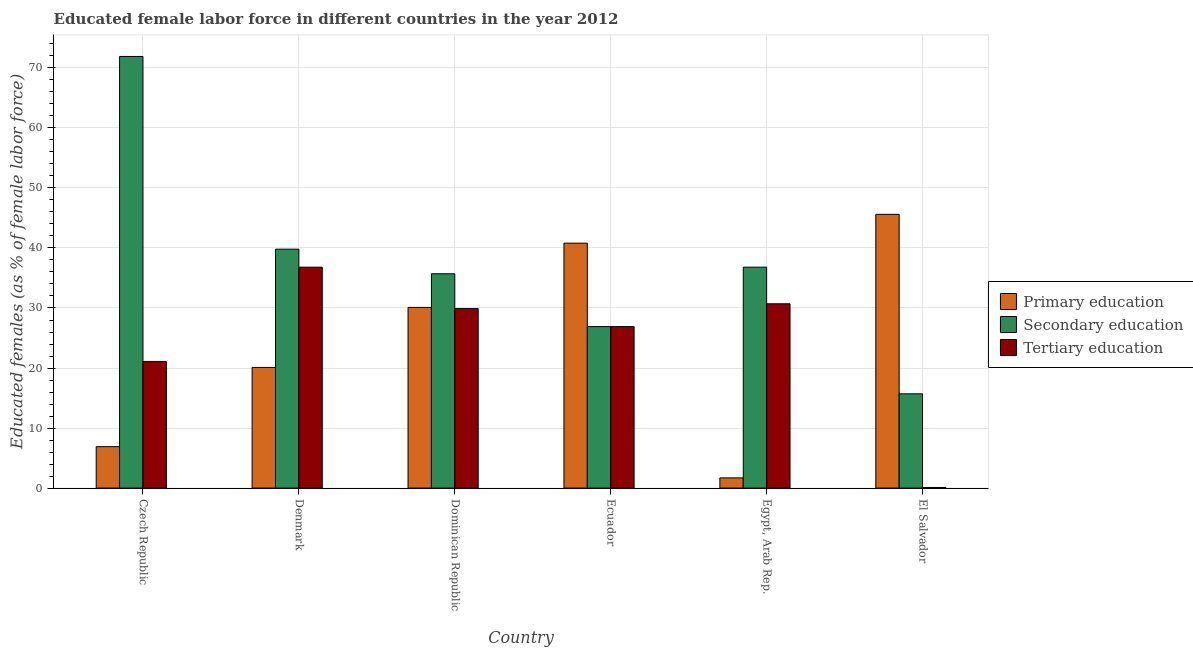How many different coloured bars are there?
Provide a succinct answer. 3. How many groups of bars are there?
Provide a succinct answer. 6. Are the number of bars per tick equal to the number of legend labels?
Offer a very short reply. Yes. Are the number of bars on each tick of the X-axis equal?
Provide a succinct answer. Yes. What is the label of the 1st group of bars from the left?
Your response must be concise. Czech Republic. What is the percentage of female labor force who received secondary education in El Salvador?
Make the answer very short. 15.7. Across all countries, what is the maximum percentage of female labor force who received secondary education?
Your response must be concise. 71.9. Across all countries, what is the minimum percentage of female labor force who received tertiary education?
Your answer should be very brief. 0.1. In which country was the percentage of female labor force who received tertiary education maximum?
Your response must be concise. Denmark. In which country was the percentage of female labor force who received primary education minimum?
Offer a terse response. Egypt, Arab Rep. What is the total percentage of female labor force who received secondary education in the graph?
Ensure brevity in your answer.  226.8. What is the difference between the percentage of female labor force who received tertiary education in Czech Republic and that in Denmark?
Your response must be concise. -15.7. What is the difference between the percentage of female labor force who received tertiary education in Denmark and the percentage of female labor force who received secondary education in Czech Republic?
Your response must be concise. -35.1. What is the average percentage of female labor force who received secondary education per country?
Your response must be concise. 37.8. What is the difference between the percentage of female labor force who received secondary education and percentage of female labor force who received tertiary education in Egypt, Arab Rep.?
Offer a terse response. 6.1. What is the ratio of the percentage of female labor force who received secondary education in Czech Republic to that in Ecuador?
Your response must be concise. 2.67. Is the percentage of female labor force who received secondary education in Czech Republic less than that in Dominican Republic?
Your response must be concise. No. What is the difference between the highest and the second highest percentage of female labor force who received tertiary education?
Ensure brevity in your answer.  6.1. What is the difference between the highest and the lowest percentage of female labor force who received secondary education?
Your response must be concise. 56.2. Is the sum of the percentage of female labor force who received primary education in Czech Republic and Ecuador greater than the maximum percentage of female labor force who received tertiary education across all countries?
Keep it short and to the point. Yes. What does the 3rd bar from the left in Denmark represents?
Your answer should be compact. Tertiary education. What does the 2nd bar from the right in Dominican Republic represents?
Provide a short and direct response. Secondary education. Is it the case that in every country, the sum of the percentage of female labor force who received primary education and percentage of female labor force who received secondary education is greater than the percentage of female labor force who received tertiary education?
Offer a terse response. Yes. How many bars are there?
Make the answer very short. 18. Are all the bars in the graph horizontal?
Provide a short and direct response. No. How many countries are there in the graph?
Provide a succinct answer. 6. Does the graph contain any zero values?
Offer a very short reply. No. Does the graph contain grids?
Provide a short and direct response. Yes. What is the title of the graph?
Give a very brief answer. Educated female labor force in different countries in the year 2012. Does "Textiles and clothing" appear as one of the legend labels in the graph?
Ensure brevity in your answer.  No. What is the label or title of the Y-axis?
Provide a short and direct response. Educated females (as % of female labor force). What is the Educated females (as % of female labor force) in Primary education in Czech Republic?
Your answer should be compact. 6.9. What is the Educated females (as % of female labor force) in Secondary education in Czech Republic?
Make the answer very short. 71.9. What is the Educated females (as % of female labor force) in Tertiary education in Czech Republic?
Make the answer very short. 21.1. What is the Educated females (as % of female labor force) of Primary education in Denmark?
Keep it short and to the point. 20.1. What is the Educated females (as % of female labor force) in Secondary education in Denmark?
Ensure brevity in your answer.  39.8. What is the Educated females (as % of female labor force) of Tertiary education in Denmark?
Your response must be concise. 36.8. What is the Educated females (as % of female labor force) of Primary education in Dominican Republic?
Keep it short and to the point. 30.1. What is the Educated females (as % of female labor force) of Secondary education in Dominican Republic?
Offer a terse response. 35.7. What is the Educated females (as % of female labor force) of Tertiary education in Dominican Republic?
Your answer should be very brief. 29.9. What is the Educated females (as % of female labor force) in Primary education in Ecuador?
Give a very brief answer. 40.8. What is the Educated females (as % of female labor force) in Secondary education in Ecuador?
Your answer should be very brief. 26.9. What is the Educated females (as % of female labor force) of Tertiary education in Ecuador?
Ensure brevity in your answer.  26.9. What is the Educated females (as % of female labor force) in Primary education in Egypt, Arab Rep.?
Give a very brief answer. 1.7. What is the Educated females (as % of female labor force) in Secondary education in Egypt, Arab Rep.?
Offer a very short reply. 36.8. What is the Educated females (as % of female labor force) of Tertiary education in Egypt, Arab Rep.?
Your answer should be compact. 30.7. What is the Educated females (as % of female labor force) of Primary education in El Salvador?
Ensure brevity in your answer.  45.6. What is the Educated females (as % of female labor force) in Secondary education in El Salvador?
Ensure brevity in your answer.  15.7. What is the Educated females (as % of female labor force) of Tertiary education in El Salvador?
Offer a very short reply. 0.1. Across all countries, what is the maximum Educated females (as % of female labor force) in Primary education?
Give a very brief answer. 45.6. Across all countries, what is the maximum Educated females (as % of female labor force) in Secondary education?
Offer a terse response. 71.9. Across all countries, what is the maximum Educated females (as % of female labor force) of Tertiary education?
Offer a terse response. 36.8. Across all countries, what is the minimum Educated females (as % of female labor force) in Primary education?
Provide a succinct answer. 1.7. Across all countries, what is the minimum Educated females (as % of female labor force) of Secondary education?
Give a very brief answer. 15.7. Across all countries, what is the minimum Educated females (as % of female labor force) of Tertiary education?
Provide a succinct answer. 0.1. What is the total Educated females (as % of female labor force) of Primary education in the graph?
Offer a terse response. 145.2. What is the total Educated females (as % of female labor force) of Secondary education in the graph?
Ensure brevity in your answer.  226.8. What is the total Educated females (as % of female labor force) of Tertiary education in the graph?
Provide a short and direct response. 145.5. What is the difference between the Educated females (as % of female labor force) in Secondary education in Czech Republic and that in Denmark?
Your answer should be very brief. 32.1. What is the difference between the Educated females (as % of female labor force) of Tertiary education in Czech Republic and that in Denmark?
Provide a succinct answer. -15.7. What is the difference between the Educated females (as % of female labor force) of Primary education in Czech Republic and that in Dominican Republic?
Your answer should be very brief. -23.2. What is the difference between the Educated females (as % of female labor force) of Secondary education in Czech Republic and that in Dominican Republic?
Your answer should be compact. 36.2. What is the difference between the Educated females (as % of female labor force) of Tertiary education in Czech Republic and that in Dominican Republic?
Your answer should be very brief. -8.8. What is the difference between the Educated females (as % of female labor force) in Primary education in Czech Republic and that in Ecuador?
Make the answer very short. -33.9. What is the difference between the Educated females (as % of female labor force) in Primary education in Czech Republic and that in Egypt, Arab Rep.?
Your answer should be compact. 5.2. What is the difference between the Educated females (as % of female labor force) of Secondary education in Czech Republic and that in Egypt, Arab Rep.?
Your response must be concise. 35.1. What is the difference between the Educated females (as % of female labor force) of Primary education in Czech Republic and that in El Salvador?
Keep it short and to the point. -38.7. What is the difference between the Educated females (as % of female labor force) of Secondary education in Czech Republic and that in El Salvador?
Your response must be concise. 56.2. What is the difference between the Educated females (as % of female labor force) in Tertiary education in Czech Republic and that in El Salvador?
Your answer should be compact. 21. What is the difference between the Educated females (as % of female labor force) of Primary education in Denmark and that in Dominican Republic?
Offer a terse response. -10. What is the difference between the Educated females (as % of female labor force) in Secondary education in Denmark and that in Dominican Republic?
Provide a short and direct response. 4.1. What is the difference between the Educated females (as % of female labor force) of Tertiary education in Denmark and that in Dominican Republic?
Your answer should be compact. 6.9. What is the difference between the Educated females (as % of female labor force) in Primary education in Denmark and that in Ecuador?
Provide a short and direct response. -20.7. What is the difference between the Educated females (as % of female labor force) of Secondary education in Denmark and that in Ecuador?
Your response must be concise. 12.9. What is the difference between the Educated females (as % of female labor force) of Tertiary education in Denmark and that in Ecuador?
Provide a succinct answer. 9.9. What is the difference between the Educated females (as % of female labor force) of Primary education in Denmark and that in El Salvador?
Provide a short and direct response. -25.5. What is the difference between the Educated females (as % of female labor force) in Secondary education in Denmark and that in El Salvador?
Your response must be concise. 24.1. What is the difference between the Educated females (as % of female labor force) of Tertiary education in Denmark and that in El Salvador?
Your response must be concise. 36.7. What is the difference between the Educated females (as % of female labor force) of Primary education in Dominican Republic and that in Ecuador?
Offer a very short reply. -10.7. What is the difference between the Educated females (as % of female labor force) of Secondary education in Dominican Republic and that in Ecuador?
Make the answer very short. 8.8. What is the difference between the Educated females (as % of female labor force) of Primary education in Dominican Republic and that in Egypt, Arab Rep.?
Your response must be concise. 28.4. What is the difference between the Educated females (as % of female labor force) of Primary education in Dominican Republic and that in El Salvador?
Keep it short and to the point. -15.5. What is the difference between the Educated females (as % of female labor force) of Secondary education in Dominican Republic and that in El Salvador?
Provide a succinct answer. 20. What is the difference between the Educated females (as % of female labor force) in Tertiary education in Dominican Republic and that in El Salvador?
Your answer should be very brief. 29.8. What is the difference between the Educated females (as % of female labor force) of Primary education in Ecuador and that in Egypt, Arab Rep.?
Provide a succinct answer. 39.1. What is the difference between the Educated females (as % of female labor force) in Tertiary education in Ecuador and that in Egypt, Arab Rep.?
Ensure brevity in your answer.  -3.8. What is the difference between the Educated females (as % of female labor force) in Primary education in Ecuador and that in El Salvador?
Give a very brief answer. -4.8. What is the difference between the Educated females (as % of female labor force) in Secondary education in Ecuador and that in El Salvador?
Your answer should be very brief. 11.2. What is the difference between the Educated females (as % of female labor force) of Tertiary education in Ecuador and that in El Salvador?
Provide a short and direct response. 26.8. What is the difference between the Educated females (as % of female labor force) in Primary education in Egypt, Arab Rep. and that in El Salvador?
Offer a very short reply. -43.9. What is the difference between the Educated females (as % of female labor force) in Secondary education in Egypt, Arab Rep. and that in El Salvador?
Ensure brevity in your answer.  21.1. What is the difference between the Educated females (as % of female labor force) of Tertiary education in Egypt, Arab Rep. and that in El Salvador?
Give a very brief answer. 30.6. What is the difference between the Educated females (as % of female labor force) in Primary education in Czech Republic and the Educated females (as % of female labor force) in Secondary education in Denmark?
Offer a very short reply. -32.9. What is the difference between the Educated females (as % of female labor force) in Primary education in Czech Republic and the Educated females (as % of female labor force) in Tertiary education in Denmark?
Give a very brief answer. -29.9. What is the difference between the Educated females (as % of female labor force) in Secondary education in Czech Republic and the Educated females (as % of female labor force) in Tertiary education in Denmark?
Offer a terse response. 35.1. What is the difference between the Educated females (as % of female labor force) in Primary education in Czech Republic and the Educated females (as % of female labor force) in Secondary education in Dominican Republic?
Make the answer very short. -28.8. What is the difference between the Educated females (as % of female labor force) of Secondary education in Czech Republic and the Educated females (as % of female labor force) of Tertiary education in Dominican Republic?
Provide a succinct answer. 42. What is the difference between the Educated females (as % of female labor force) of Primary education in Czech Republic and the Educated females (as % of female labor force) of Secondary education in Ecuador?
Provide a short and direct response. -20. What is the difference between the Educated females (as % of female labor force) in Secondary education in Czech Republic and the Educated females (as % of female labor force) in Tertiary education in Ecuador?
Make the answer very short. 45. What is the difference between the Educated females (as % of female labor force) in Primary education in Czech Republic and the Educated females (as % of female labor force) in Secondary education in Egypt, Arab Rep.?
Provide a short and direct response. -29.9. What is the difference between the Educated females (as % of female labor force) in Primary education in Czech Republic and the Educated females (as % of female labor force) in Tertiary education in Egypt, Arab Rep.?
Your response must be concise. -23.8. What is the difference between the Educated females (as % of female labor force) in Secondary education in Czech Republic and the Educated females (as % of female labor force) in Tertiary education in Egypt, Arab Rep.?
Make the answer very short. 41.2. What is the difference between the Educated females (as % of female labor force) in Primary education in Czech Republic and the Educated females (as % of female labor force) in Secondary education in El Salvador?
Give a very brief answer. -8.8. What is the difference between the Educated females (as % of female labor force) in Secondary education in Czech Republic and the Educated females (as % of female labor force) in Tertiary education in El Salvador?
Keep it short and to the point. 71.8. What is the difference between the Educated females (as % of female labor force) in Primary education in Denmark and the Educated females (as % of female labor force) in Secondary education in Dominican Republic?
Give a very brief answer. -15.6. What is the difference between the Educated females (as % of female labor force) of Primary education in Denmark and the Educated females (as % of female labor force) of Tertiary education in Dominican Republic?
Give a very brief answer. -9.8. What is the difference between the Educated females (as % of female labor force) in Secondary education in Denmark and the Educated females (as % of female labor force) in Tertiary education in Dominican Republic?
Your response must be concise. 9.9. What is the difference between the Educated females (as % of female labor force) of Secondary education in Denmark and the Educated females (as % of female labor force) of Tertiary education in Ecuador?
Keep it short and to the point. 12.9. What is the difference between the Educated females (as % of female labor force) of Primary education in Denmark and the Educated females (as % of female labor force) of Secondary education in Egypt, Arab Rep.?
Your answer should be compact. -16.7. What is the difference between the Educated females (as % of female labor force) of Primary education in Denmark and the Educated females (as % of female labor force) of Tertiary education in Egypt, Arab Rep.?
Your response must be concise. -10.6. What is the difference between the Educated females (as % of female labor force) in Primary education in Denmark and the Educated females (as % of female labor force) in Secondary education in El Salvador?
Your answer should be very brief. 4.4. What is the difference between the Educated females (as % of female labor force) of Primary education in Denmark and the Educated females (as % of female labor force) of Tertiary education in El Salvador?
Your answer should be very brief. 20. What is the difference between the Educated females (as % of female labor force) of Secondary education in Denmark and the Educated females (as % of female labor force) of Tertiary education in El Salvador?
Ensure brevity in your answer.  39.7. What is the difference between the Educated females (as % of female labor force) of Primary education in Dominican Republic and the Educated females (as % of female labor force) of Secondary education in Ecuador?
Provide a succinct answer. 3.2. What is the difference between the Educated females (as % of female labor force) in Secondary education in Dominican Republic and the Educated females (as % of female labor force) in Tertiary education in Ecuador?
Offer a very short reply. 8.8. What is the difference between the Educated females (as % of female labor force) of Primary education in Dominican Republic and the Educated females (as % of female labor force) of Tertiary education in Egypt, Arab Rep.?
Offer a very short reply. -0.6. What is the difference between the Educated females (as % of female labor force) in Secondary education in Dominican Republic and the Educated females (as % of female labor force) in Tertiary education in El Salvador?
Give a very brief answer. 35.6. What is the difference between the Educated females (as % of female labor force) in Primary education in Ecuador and the Educated females (as % of female labor force) in Secondary education in El Salvador?
Your answer should be compact. 25.1. What is the difference between the Educated females (as % of female labor force) of Primary education in Ecuador and the Educated females (as % of female labor force) of Tertiary education in El Salvador?
Your response must be concise. 40.7. What is the difference between the Educated females (as % of female labor force) of Secondary education in Ecuador and the Educated females (as % of female labor force) of Tertiary education in El Salvador?
Your answer should be compact. 26.8. What is the difference between the Educated females (as % of female labor force) of Primary education in Egypt, Arab Rep. and the Educated females (as % of female labor force) of Secondary education in El Salvador?
Offer a terse response. -14. What is the difference between the Educated females (as % of female labor force) of Secondary education in Egypt, Arab Rep. and the Educated females (as % of female labor force) of Tertiary education in El Salvador?
Offer a very short reply. 36.7. What is the average Educated females (as % of female labor force) of Primary education per country?
Give a very brief answer. 24.2. What is the average Educated females (as % of female labor force) of Secondary education per country?
Your answer should be very brief. 37.8. What is the average Educated females (as % of female labor force) in Tertiary education per country?
Give a very brief answer. 24.25. What is the difference between the Educated females (as % of female labor force) in Primary education and Educated females (as % of female labor force) in Secondary education in Czech Republic?
Offer a terse response. -65. What is the difference between the Educated females (as % of female labor force) of Primary education and Educated females (as % of female labor force) of Tertiary education in Czech Republic?
Keep it short and to the point. -14.2. What is the difference between the Educated females (as % of female labor force) of Secondary education and Educated females (as % of female labor force) of Tertiary education in Czech Republic?
Provide a succinct answer. 50.8. What is the difference between the Educated females (as % of female labor force) in Primary education and Educated females (as % of female labor force) in Secondary education in Denmark?
Provide a succinct answer. -19.7. What is the difference between the Educated females (as % of female labor force) of Primary education and Educated females (as % of female labor force) of Tertiary education in Denmark?
Provide a succinct answer. -16.7. What is the difference between the Educated females (as % of female labor force) in Secondary education and Educated females (as % of female labor force) in Tertiary education in Denmark?
Your answer should be very brief. 3. What is the difference between the Educated females (as % of female labor force) of Primary education and Educated females (as % of female labor force) of Secondary education in Dominican Republic?
Make the answer very short. -5.6. What is the difference between the Educated females (as % of female labor force) of Primary education and Educated females (as % of female labor force) of Tertiary education in Dominican Republic?
Offer a very short reply. 0.2. What is the difference between the Educated females (as % of female labor force) in Secondary education and Educated females (as % of female labor force) in Tertiary education in Dominican Republic?
Provide a succinct answer. 5.8. What is the difference between the Educated females (as % of female labor force) in Primary education and Educated females (as % of female labor force) in Tertiary education in Ecuador?
Make the answer very short. 13.9. What is the difference between the Educated females (as % of female labor force) of Primary education and Educated females (as % of female labor force) of Secondary education in Egypt, Arab Rep.?
Give a very brief answer. -35.1. What is the difference between the Educated females (as % of female labor force) in Secondary education and Educated females (as % of female labor force) in Tertiary education in Egypt, Arab Rep.?
Your answer should be very brief. 6.1. What is the difference between the Educated females (as % of female labor force) of Primary education and Educated females (as % of female labor force) of Secondary education in El Salvador?
Keep it short and to the point. 29.9. What is the difference between the Educated females (as % of female labor force) in Primary education and Educated females (as % of female labor force) in Tertiary education in El Salvador?
Your answer should be very brief. 45.5. What is the ratio of the Educated females (as % of female labor force) of Primary education in Czech Republic to that in Denmark?
Your answer should be compact. 0.34. What is the ratio of the Educated females (as % of female labor force) of Secondary education in Czech Republic to that in Denmark?
Offer a very short reply. 1.81. What is the ratio of the Educated females (as % of female labor force) of Tertiary education in Czech Republic to that in Denmark?
Provide a short and direct response. 0.57. What is the ratio of the Educated females (as % of female labor force) in Primary education in Czech Republic to that in Dominican Republic?
Give a very brief answer. 0.23. What is the ratio of the Educated females (as % of female labor force) of Secondary education in Czech Republic to that in Dominican Republic?
Provide a short and direct response. 2.01. What is the ratio of the Educated females (as % of female labor force) in Tertiary education in Czech Republic to that in Dominican Republic?
Ensure brevity in your answer.  0.71. What is the ratio of the Educated females (as % of female labor force) in Primary education in Czech Republic to that in Ecuador?
Keep it short and to the point. 0.17. What is the ratio of the Educated females (as % of female labor force) in Secondary education in Czech Republic to that in Ecuador?
Offer a terse response. 2.67. What is the ratio of the Educated females (as % of female labor force) of Tertiary education in Czech Republic to that in Ecuador?
Your response must be concise. 0.78. What is the ratio of the Educated females (as % of female labor force) of Primary education in Czech Republic to that in Egypt, Arab Rep.?
Your answer should be very brief. 4.06. What is the ratio of the Educated females (as % of female labor force) in Secondary education in Czech Republic to that in Egypt, Arab Rep.?
Your answer should be very brief. 1.95. What is the ratio of the Educated females (as % of female labor force) of Tertiary education in Czech Republic to that in Egypt, Arab Rep.?
Ensure brevity in your answer.  0.69. What is the ratio of the Educated females (as % of female labor force) of Primary education in Czech Republic to that in El Salvador?
Offer a terse response. 0.15. What is the ratio of the Educated females (as % of female labor force) of Secondary education in Czech Republic to that in El Salvador?
Ensure brevity in your answer.  4.58. What is the ratio of the Educated females (as % of female labor force) in Tertiary education in Czech Republic to that in El Salvador?
Your answer should be compact. 211. What is the ratio of the Educated females (as % of female labor force) in Primary education in Denmark to that in Dominican Republic?
Your response must be concise. 0.67. What is the ratio of the Educated females (as % of female labor force) in Secondary education in Denmark to that in Dominican Republic?
Offer a very short reply. 1.11. What is the ratio of the Educated females (as % of female labor force) in Tertiary education in Denmark to that in Dominican Republic?
Your response must be concise. 1.23. What is the ratio of the Educated females (as % of female labor force) of Primary education in Denmark to that in Ecuador?
Make the answer very short. 0.49. What is the ratio of the Educated females (as % of female labor force) of Secondary education in Denmark to that in Ecuador?
Give a very brief answer. 1.48. What is the ratio of the Educated females (as % of female labor force) in Tertiary education in Denmark to that in Ecuador?
Provide a succinct answer. 1.37. What is the ratio of the Educated females (as % of female labor force) in Primary education in Denmark to that in Egypt, Arab Rep.?
Provide a succinct answer. 11.82. What is the ratio of the Educated females (as % of female labor force) in Secondary education in Denmark to that in Egypt, Arab Rep.?
Give a very brief answer. 1.08. What is the ratio of the Educated females (as % of female labor force) in Tertiary education in Denmark to that in Egypt, Arab Rep.?
Provide a succinct answer. 1.2. What is the ratio of the Educated females (as % of female labor force) of Primary education in Denmark to that in El Salvador?
Keep it short and to the point. 0.44. What is the ratio of the Educated females (as % of female labor force) of Secondary education in Denmark to that in El Salvador?
Keep it short and to the point. 2.54. What is the ratio of the Educated females (as % of female labor force) in Tertiary education in Denmark to that in El Salvador?
Your answer should be compact. 368. What is the ratio of the Educated females (as % of female labor force) in Primary education in Dominican Republic to that in Ecuador?
Provide a succinct answer. 0.74. What is the ratio of the Educated females (as % of female labor force) in Secondary education in Dominican Republic to that in Ecuador?
Keep it short and to the point. 1.33. What is the ratio of the Educated females (as % of female labor force) of Tertiary education in Dominican Republic to that in Ecuador?
Make the answer very short. 1.11. What is the ratio of the Educated females (as % of female labor force) of Primary education in Dominican Republic to that in Egypt, Arab Rep.?
Keep it short and to the point. 17.71. What is the ratio of the Educated females (as % of female labor force) of Secondary education in Dominican Republic to that in Egypt, Arab Rep.?
Keep it short and to the point. 0.97. What is the ratio of the Educated females (as % of female labor force) of Tertiary education in Dominican Republic to that in Egypt, Arab Rep.?
Your response must be concise. 0.97. What is the ratio of the Educated females (as % of female labor force) in Primary education in Dominican Republic to that in El Salvador?
Give a very brief answer. 0.66. What is the ratio of the Educated females (as % of female labor force) of Secondary education in Dominican Republic to that in El Salvador?
Give a very brief answer. 2.27. What is the ratio of the Educated females (as % of female labor force) in Tertiary education in Dominican Republic to that in El Salvador?
Offer a terse response. 299. What is the ratio of the Educated females (as % of female labor force) in Secondary education in Ecuador to that in Egypt, Arab Rep.?
Your answer should be very brief. 0.73. What is the ratio of the Educated females (as % of female labor force) in Tertiary education in Ecuador to that in Egypt, Arab Rep.?
Your response must be concise. 0.88. What is the ratio of the Educated females (as % of female labor force) of Primary education in Ecuador to that in El Salvador?
Make the answer very short. 0.89. What is the ratio of the Educated females (as % of female labor force) of Secondary education in Ecuador to that in El Salvador?
Make the answer very short. 1.71. What is the ratio of the Educated females (as % of female labor force) in Tertiary education in Ecuador to that in El Salvador?
Your answer should be compact. 269. What is the ratio of the Educated females (as % of female labor force) in Primary education in Egypt, Arab Rep. to that in El Salvador?
Provide a succinct answer. 0.04. What is the ratio of the Educated females (as % of female labor force) in Secondary education in Egypt, Arab Rep. to that in El Salvador?
Offer a very short reply. 2.34. What is the ratio of the Educated females (as % of female labor force) in Tertiary education in Egypt, Arab Rep. to that in El Salvador?
Your answer should be very brief. 307. What is the difference between the highest and the second highest Educated females (as % of female labor force) in Primary education?
Provide a short and direct response. 4.8. What is the difference between the highest and the second highest Educated females (as % of female labor force) in Secondary education?
Provide a succinct answer. 32.1. What is the difference between the highest and the lowest Educated females (as % of female labor force) of Primary education?
Make the answer very short. 43.9. What is the difference between the highest and the lowest Educated females (as % of female labor force) of Secondary education?
Provide a succinct answer. 56.2. What is the difference between the highest and the lowest Educated females (as % of female labor force) of Tertiary education?
Offer a very short reply. 36.7. 